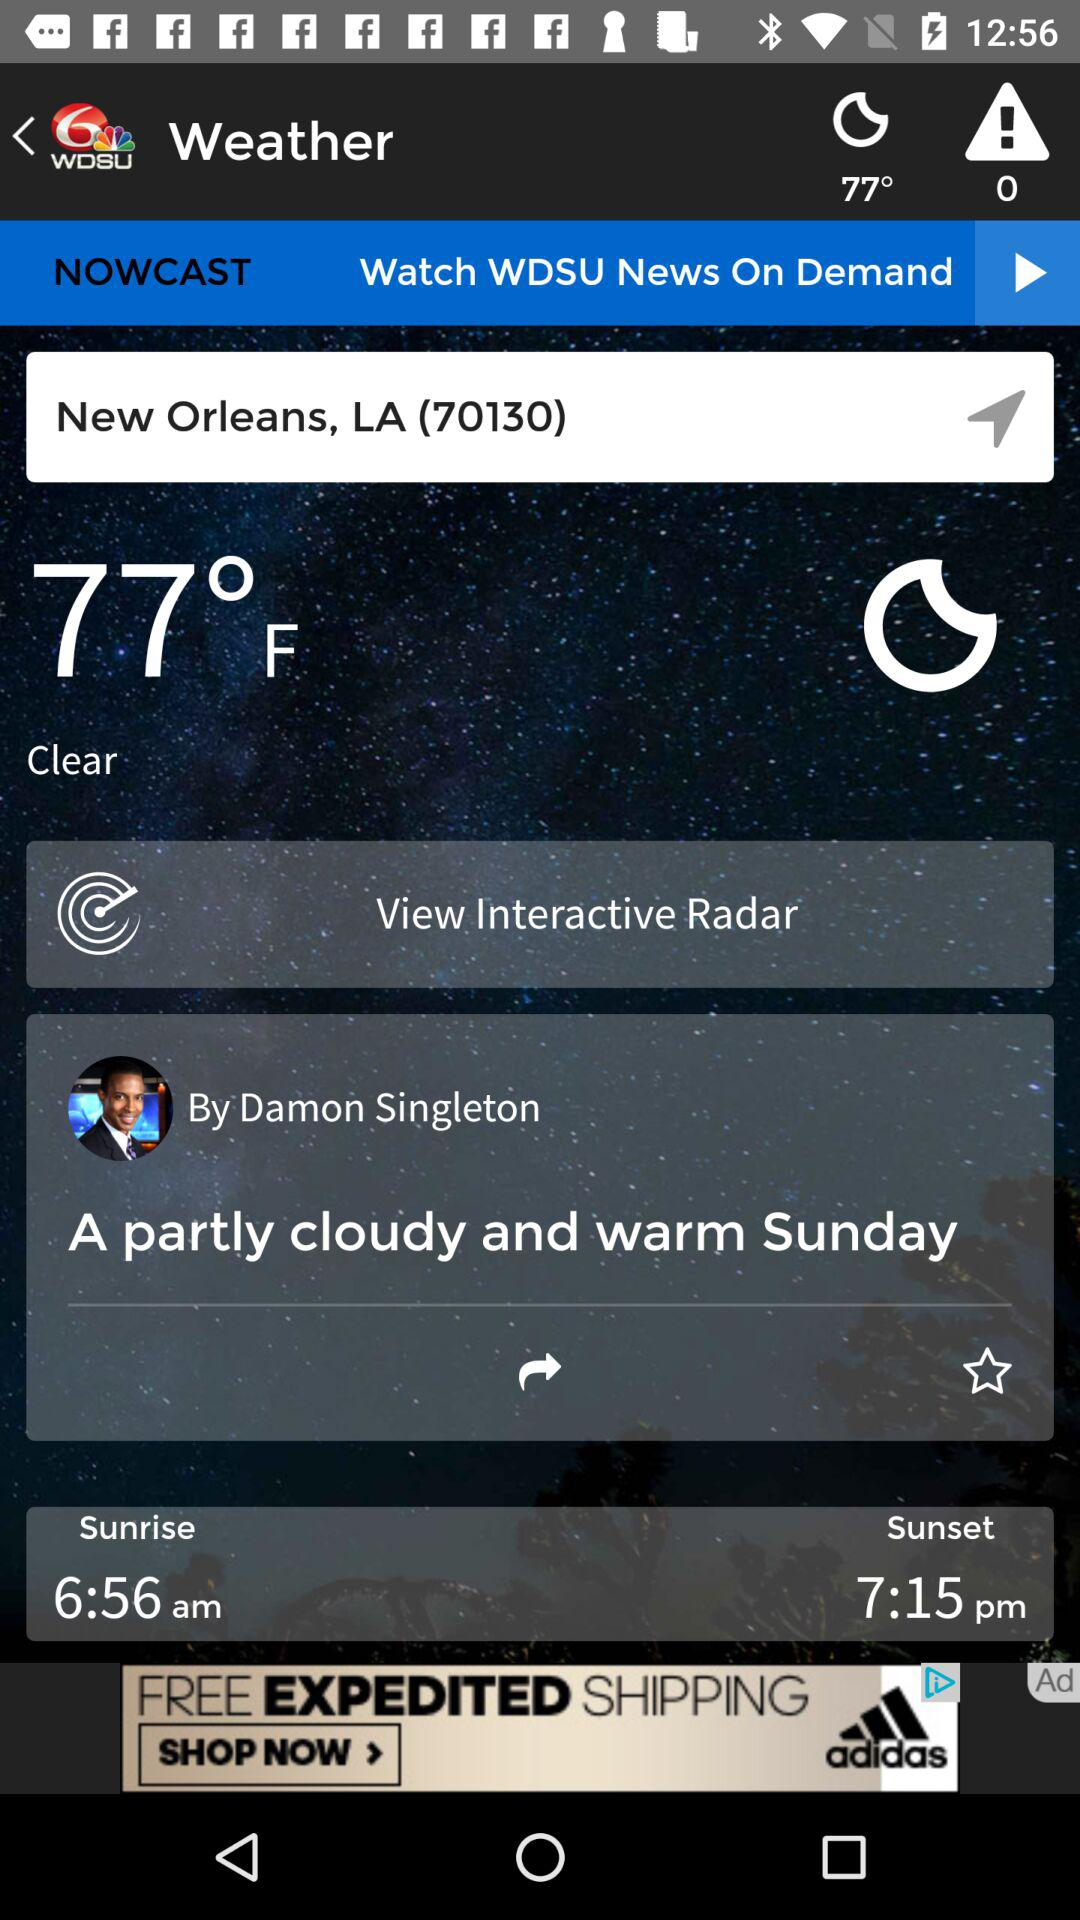What is the temperature? The temperature is 77 °F. 